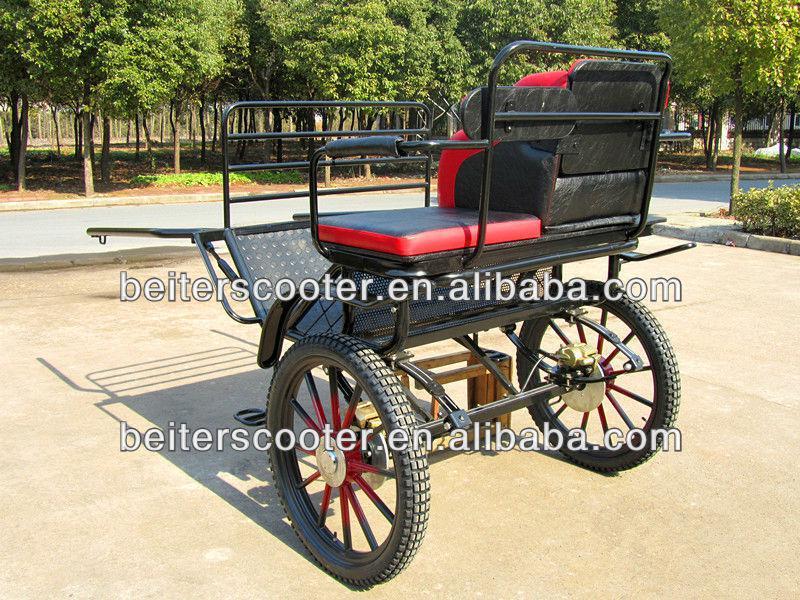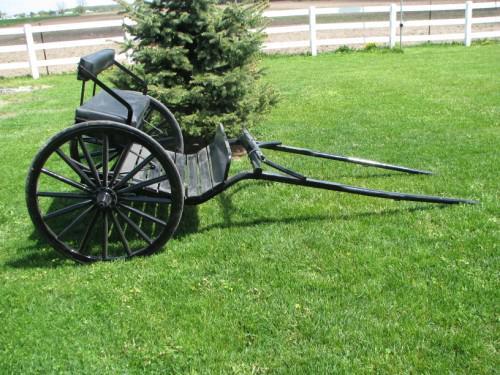The first image is the image on the left, the second image is the image on the right. Evaluate the accuracy of this statement regarding the images: "One of the carriages is red and black.". Is it true? Answer yes or no. Yes. The first image is the image on the left, the second image is the image on the right. Examine the images to the left and right. Is the description "A two-wheeled black cart is displayed in a side view on grass, with its leads touching the ground." accurate? Answer yes or no. Yes. 